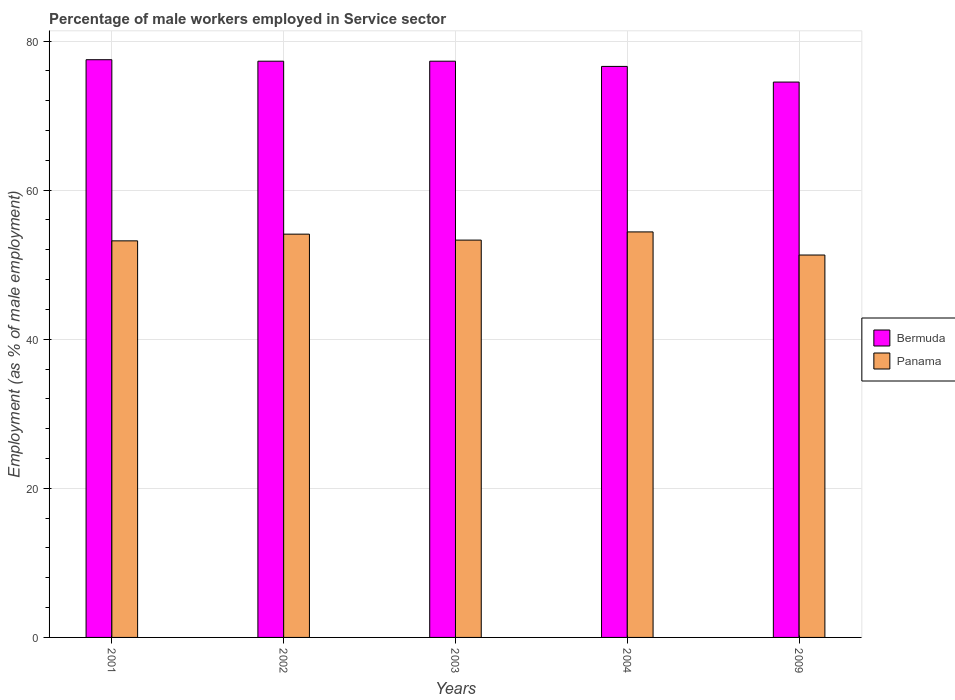How many different coloured bars are there?
Your answer should be compact. 2. Are the number of bars per tick equal to the number of legend labels?
Make the answer very short. Yes. Are the number of bars on each tick of the X-axis equal?
Your answer should be compact. Yes. How many bars are there on the 5th tick from the left?
Provide a succinct answer. 2. How many bars are there on the 1st tick from the right?
Your answer should be compact. 2. What is the percentage of male workers employed in Service sector in Panama in 2009?
Offer a terse response. 51.3. Across all years, what is the maximum percentage of male workers employed in Service sector in Bermuda?
Provide a short and direct response. 77.5. Across all years, what is the minimum percentage of male workers employed in Service sector in Panama?
Offer a terse response. 51.3. In which year was the percentage of male workers employed in Service sector in Bermuda minimum?
Provide a short and direct response. 2009. What is the total percentage of male workers employed in Service sector in Bermuda in the graph?
Offer a terse response. 383.2. What is the difference between the percentage of male workers employed in Service sector in Panama in 2004 and that in 2009?
Offer a terse response. 3.1. What is the difference between the percentage of male workers employed in Service sector in Bermuda in 2003 and the percentage of male workers employed in Service sector in Panama in 2001?
Your response must be concise. 24.1. What is the average percentage of male workers employed in Service sector in Bermuda per year?
Keep it short and to the point. 76.64. In the year 2004, what is the difference between the percentage of male workers employed in Service sector in Bermuda and percentage of male workers employed in Service sector in Panama?
Ensure brevity in your answer.  22.2. What is the ratio of the percentage of male workers employed in Service sector in Bermuda in 2001 to that in 2003?
Offer a terse response. 1. What is the difference between the highest and the second highest percentage of male workers employed in Service sector in Panama?
Keep it short and to the point. 0.3. What is the difference between the highest and the lowest percentage of male workers employed in Service sector in Panama?
Offer a very short reply. 3.1. What does the 2nd bar from the left in 2004 represents?
Your answer should be compact. Panama. What does the 1st bar from the right in 2004 represents?
Your answer should be compact. Panama. How many bars are there?
Offer a terse response. 10. How many years are there in the graph?
Ensure brevity in your answer.  5. Does the graph contain any zero values?
Make the answer very short. No. What is the title of the graph?
Make the answer very short. Percentage of male workers employed in Service sector. What is the label or title of the Y-axis?
Offer a terse response. Employment (as % of male employment). What is the Employment (as % of male employment) in Bermuda in 2001?
Keep it short and to the point. 77.5. What is the Employment (as % of male employment) of Panama in 2001?
Ensure brevity in your answer.  53.2. What is the Employment (as % of male employment) in Bermuda in 2002?
Ensure brevity in your answer.  77.3. What is the Employment (as % of male employment) in Panama in 2002?
Your answer should be compact. 54.1. What is the Employment (as % of male employment) of Bermuda in 2003?
Offer a very short reply. 77.3. What is the Employment (as % of male employment) in Panama in 2003?
Provide a short and direct response. 53.3. What is the Employment (as % of male employment) of Bermuda in 2004?
Make the answer very short. 76.6. What is the Employment (as % of male employment) in Panama in 2004?
Ensure brevity in your answer.  54.4. What is the Employment (as % of male employment) in Bermuda in 2009?
Keep it short and to the point. 74.5. What is the Employment (as % of male employment) of Panama in 2009?
Your answer should be compact. 51.3. Across all years, what is the maximum Employment (as % of male employment) in Bermuda?
Offer a terse response. 77.5. Across all years, what is the maximum Employment (as % of male employment) of Panama?
Offer a very short reply. 54.4. Across all years, what is the minimum Employment (as % of male employment) of Bermuda?
Ensure brevity in your answer.  74.5. Across all years, what is the minimum Employment (as % of male employment) of Panama?
Give a very brief answer. 51.3. What is the total Employment (as % of male employment) in Bermuda in the graph?
Your answer should be compact. 383.2. What is the total Employment (as % of male employment) of Panama in the graph?
Your answer should be very brief. 266.3. What is the difference between the Employment (as % of male employment) in Bermuda in 2001 and that in 2002?
Provide a succinct answer. 0.2. What is the difference between the Employment (as % of male employment) in Panama in 2001 and that in 2002?
Provide a succinct answer. -0.9. What is the difference between the Employment (as % of male employment) of Bermuda in 2001 and that in 2003?
Make the answer very short. 0.2. What is the difference between the Employment (as % of male employment) in Bermuda in 2001 and that in 2004?
Make the answer very short. 0.9. What is the difference between the Employment (as % of male employment) of Panama in 2002 and that in 2003?
Your answer should be compact. 0.8. What is the difference between the Employment (as % of male employment) in Panama in 2002 and that in 2004?
Make the answer very short. -0.3. What is the difference between the Employment (as % of male employment) in Panama in 2002 and that in 2009?
Your answer should be very brief. 2.8. What is the difference between the Employment (as % of male employment) in Panama in 2003 and that in 2004?
Give a very brief answer. -1.1. What is the difference between the Employment (as % of male employment) of Bermuda in 2004 and that in 2009?
Keep it short and to the point. 2.1. What is the difference between the Employment (as % of male employment) of Bermuda in 2001 and the Employment (as % of male employment) of Panama in 2002?
Ensure brevity in your answer.  23.4. What is the difference between the Employment (as % of male employment) in Bermuda in 2001 and the Employment (as % of male employment) in Panama in 2003?
Give a very brief answer. 24.2. What is the difference between the Employment (as % of male employment) in Bermuda in 2001 and the Employment (as % of male employment) in Panama in 2004?
Offer a terse response. 23.1. What is the difference between the Employment (as % of male employment) in Bermuda in 2001 and the Employment (as % of male employment) in Panama in 2009?
Your answer should be compact. 26.2. What is the difference between the Employment (as % of male employment) of Bermuda in 2002 and the Employment (as % of male employment) of Panama in 2004?
Keep it short and to the point. 22.9. What is the difference between the Employment (as % of male employment) in Bermuda in 2002 and the Employment (as % of male employment) in Panama in 2009?
Provide a short and direct response. 26. What is the difference between the Employment (as % of male employment) of Bermuda in 2003 and the Employment (as % of male employment) of Panama in 2004?
Provide a succinct answer. 22.9. What is the difference between the Employment (as % of male employment) of Bermuda in 2004 and the Employment (as % of male employment) of Panama in 2009?
Offer a terse response. 25.3. What is the average Employment (as % of male employment) in Bermuda per year?
Keep it short and to the point. 76.64. What is the average Employment (as % of male employment) in Panama per year?
Ensure brevity in your answer.  53.26. In the year 2001, what is the difference between the Employment (as % of male employment) in Bermuda and Employment (as % of male employment) in Panama?
Provide a succinct answer. 24.3. In the year 2002, what is the difference between the Employment (as % of male employment) in Bermuda and Employment (as % of male employment) in Panama?
Your answer should be compact. 23.2. In the year 2003, what is the difference between the Employment (as % of male employment) in Bermuda and Employment (as % of male employment) in Panama?
Provide a succinct answer. 24. In the year 2004, what is the difference between the Employment (as % of male employment) of Bermuda and Employment (as % of male employment) of Panama?
Ensure brevity in your answer.  22.2. In the year 2009, what is the difference between the Employment (as % of male employment) of Bermuda and Employment (as % of male employment) of Panama?
Your answer should be very brief. 23.2. What is the ratio of the Employment (as % of male employment) in Bermuda in 2001 to that in 2002?
Give a very brief answer. 1. What is the ratio of the Employment (as % of male employment) of Panama in 2001 to that in 2002?
Provide a succinct answer. 0.98. What is the ratio of the Employment (as % of male employment) in Bermuda in 2001 to that in 2003?
Your answer should be compact. 1. What is the ratio of the Employment (as % of male employment) in Bermuda in 2001 to that in 2004?
Provide a succinct answer. 1.01. What is the ratio of the Employment (as % of male employment) in Panama in 2001 to that in 2004?
Give a very brief answer. 0.98. What is the ratio of the Employment (as % of male employment) in Bermuda in 2001 to that in 2009?
Offer a very short reply. 1.04. What is the ratio of the Employment (as % of male employment) of Panama in 2001 to that in 2009?
Make the answer very short. 1.04. What is the ratio of the Employment (as % of male employment) in Panama in 2002 to that in 2003?
Keep it short and to the point. 1.01. What is the ratio of the Employment (as % of male employment) of Bermuda in 2002 to that in 2004?
Your answer should be very brief. 1.01. What is the ratio of the Employment (as % of male employment) of Panama in 2002 to that in 2004?
Offer a very short reply. 0.99. What is the ratio of the Employment (as % of male employment) in Bermuda in 2002 to that in 2009?
Your answer should be compact. 1.04. What is the ratio of the Employment (as % of male employment) in Panama in 2002 to that in 2009?
Provide a succinct answer. 1.05. What is the ratio of the Employment (as % of male employment) of Bermuda in 2003 to that in 2004?
Provide a succinct answer. 1.01. What is the ratio of the Employment (as % of male employment) of Panama in 2003 to that in 2004?
Make the answer very short. 0.98. What is the ratio of the Employment (as % of male employment) of Bermuda in 2003 to that in 2009?
Your answer should be compact. 1.04. What is the ratio of the Employment (as % of male employment) of Panama in 2003 to that in 2009?
Your response must be concise. 1.04. What is the ratio of the Employment (as % of male employment) of Bermuda in 2004 to that in 2009?
Your answer should be very brief. 1.03. What is the ratio of the Employment (as % of male employment) in Panama in 2004 to that in 2009?
Ensure brevity in your answer.  1.06. What is the difference between the highest and the second highest Employment (as % of male employment) in Panama?
Keep it short and to the point. 0.3. 